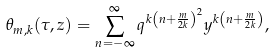<formula> <loc_0><loc_0><loc_500><loc_500>\theta _ { m , k } ( \tau , z ) = \sum _ { n = - \infty } ^ { \infty } q ^ { k \left ( n + \frac { m } { 2 k } \right ) ^ { 2 } } y ^ { k \left ( n + \frac { m } { 2 k } \right ) } ,</formula> 